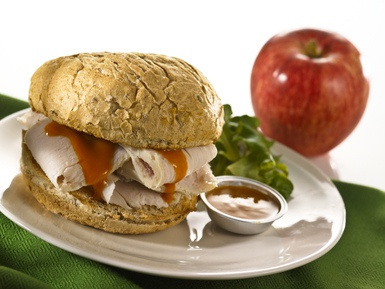Describe the objects in this image and their specific colors. I can see sandwich in white, olive, and tan tones, dining table in white, darkgreen, black, and gray tones, and apple in white, brown, and maroon tones in this image. 